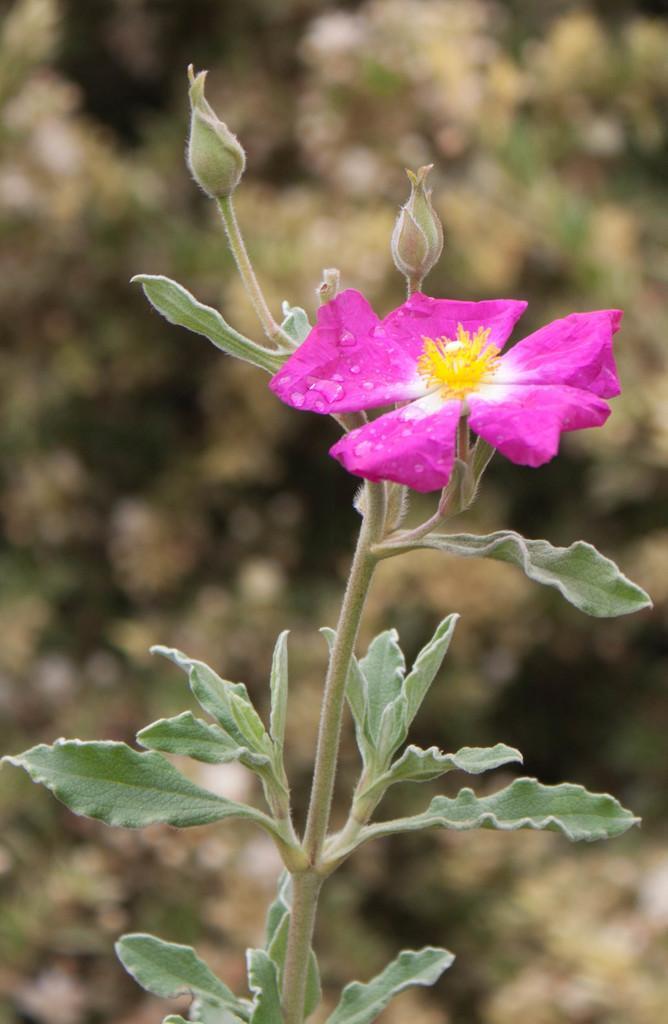Can you describe this image briefly? In the foreground of the picture there is a plant, to the plant there are buds and a flower. The background is blurred. 